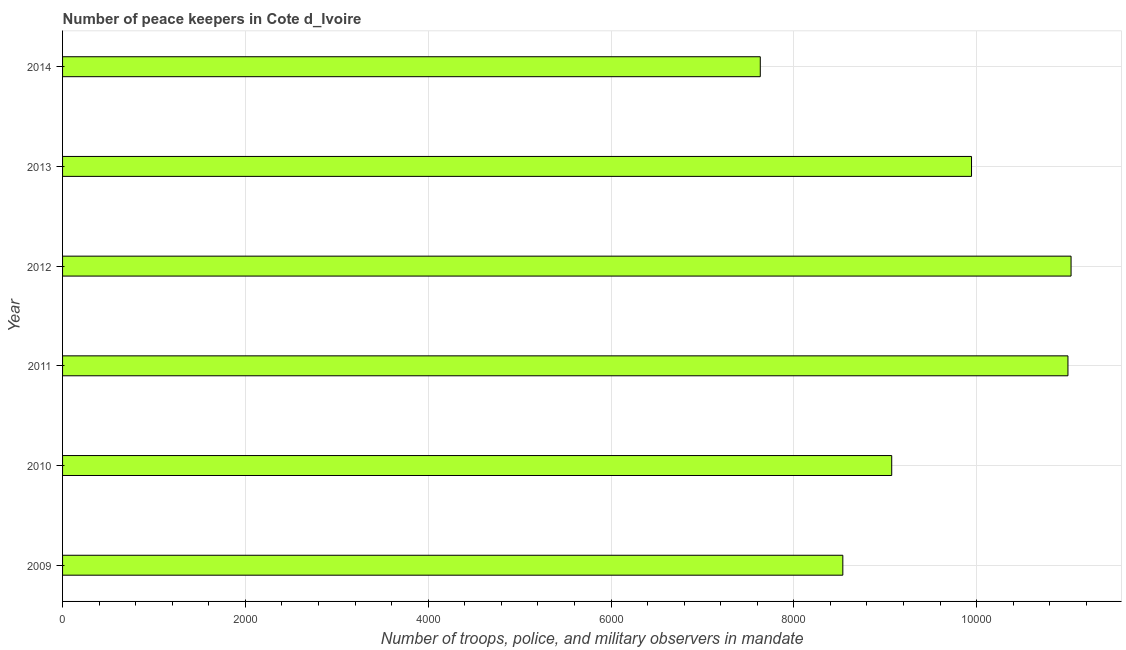What is the title of the graph?
Provide a short and direct response. Number of peace keepers in Cote d_Ivoire. What is the label or title of the X-axis?
Ensure brevity in your answer.  Number of troops, police, and military observers in mandate. What is the number of peace keepers in 2014?
Give a very brief answer. 7633. Across all years, what is the maximum number of peace keepers?
Offer a terse response. 1.10e+04. Across all years, what is the minimum number of peace keepers?
Offer a very short reply. 7633. What is the sum of the number of peace keepers?
Provide a short and direct response. 5.72e+04. What is the difference between the number of peace keepers in 2012 and 2013?
Keep it short and to the point. 1089. What is the average number of peace keepers per year?
Keep it short and to the point. 9536. What is the median number of peace keepers?
Provide a short and direct response. 9507.5. In how many years, is the number of peace keepers greater than 9600 ?
Your answer should be compact. 3. What is the ratio of the number of peace keepers in 2012 to that in 2014?
Provide a succinct answer. 1.45. Is the number of peace keepers in 2009 less than that in 2014?
Give a very brief answer. No. What is the difference between the highest and the second highest number of peace keepers?
Keep it short and to the point. 34. What is the difference between the highest and the lowest number of peace keepers?
Offer a terse response. 3400. Are all the bars in the graph horizontal?
Offer a very short reply. Yes. How many years are there in the graph?
Make the answer very short. 6. What is the difference between two consecutive major ticks on the X-axis?
Offer a very short reply. 2000. Are the values on the major ticks of X-axis written in scientific E-notation?
Your response must be concise. No. What is the Number of troops, police, and military observers in mandate of 2009?
Provide a short and direct response. 8536. What is the Number of troops, police, and military observers in mandate in 2010?
Give a very brief answer. 9071. What is the Number of troops, police, and military observers in mandate of 2011?
Your response must be concise. 1.10e+04. What is the Number of troops, police, and military observers in mandate in 2012?
Provide a succinct answer. 1.10e+04. What is the Number of troops, police, and military observers in mandate of 2013?
Make the answer very short. 9944. What is the Number of troops, police, and military observers in mandate in 2014?
Make the answer very short. 7633. What is the difference between the Number of troops, police, and military observers in mandate in 2009 and 2010?
Your answer should be very brief. -535. What is the difference between the Number of troops, police, and military observers in mandate in 2009 and 2011?
Provide a short and direct response. -2463. What is the difference between the Number of troops, police, and military observers in mandate in 2009 and 2012?
Give a very brief answer. -2497. What is the difference between the Number of troops, police, and military observers in mandate in 2009 and 2013?
Give a very brief answer. -1408. What is the difference between the Number of troops, police, and military observers in mandate in 2009 and 2014?
Your answer should be very brief. 903. What is the difference between the Number of troops, police, and military observers in mandate in 2010 and 2011?
Ensure brevity in your answer.  -1928. What is the difference between the Number of troops, police, and military observers in mandate in 2010 and 2012?
Offer a terse response. -1962. What is the difference between the Number of troops, police, and military observers in mandate in 2010 and 2013?
Offer a very short reply. -873. What is the difference between the Number of troops, police, and military observers in mandate in 2010 and 2014?
Offer a very short reply. 1438. What is the difference between the Number of troops, police, and military observers in mandate in 2011 and 2012?
Offer a very short reply. -34. What is the difference between the Number of troops, police, and military observers in mandate in 2011 and 2013?
Give a very brief answer. 1055. What is the difference between the Number of troops, police, and military observers in mandate in 2011 and 2014?
Give a very brief answer. 3366. What is the difference between the Number of troops, police, and military observers in mandate in 2012 and 2013?
Your response must be concise. 1089. What is the difference between the Number of troops, police, and military observers in mandate in 2012 and 2014?
Your answer should be very brief. 3400. What is the difference between the Number of troops, police, and military observers in mandate in 2013 and 2014?
Offer a terse response. 2311. What is the ratio of the Number of troops, police, and military observers in mandate in 2009 to that in 2010?
Keep it short and to the point. 0.94. What is the ratio of the Number of troops, police, and military observers in mandate in 2009 to that in 2011?
Offer a very short reply. 0.78. What is the ratio of the Number of troops, police, and military observers in mandate in 2009 to that in 2012?
Keep it short and to the point. 0.77. What is the ratio of the Number of troops, police, and military observers in mandate in 2009 to that in 2013?
Ensure brevity in your answer.  0.86. What is the ratio of the Number of troops, police, and military observers in mandate in 2009 to that in 2014?
Make the answer very short. 1.12. What is the ratio of the Number of troops, police, and military observers in mandate in 2010 to that in 2011?
Ensure brevity in your answer.  0.82. What is the ratio of the Number of troops, police, and military observers in mandate in 2010 to that in 2012?
Offer a terse response. 0.82. What is the ratio of the Number of troops, police, and military observers in mandate in 2010 to that in 2013?
Keep it short and to the point. 0.91. What is the ratio of the Number of troops, police, and military observers in mandate in 2010 to that in 2014?
Keep it short and to the point. 1.19. What is the ratio of the Number of troops, police, and military observers in mandate in 2011 to that in 2013?
Give a very brief answer. 1.11. What is the ratio of the Number of troops, police, and military observers in mandate in 2011 to that in 2014?
Offer a terse response. 1.44. What is the ratio of the Number of troops, police, and military observers in mandate in 2012 to that in 2013?
Keep it short and to the point. 1.11. What is the ratio of the Number of troops, police, and military observers in mandate in 2012 to that in 2014?
Give a very brief answer. 1.45. What is the ratio of the Number of troops, police, and military observers in mandate in 2013 to that in 2014?
Your answer should be compact. 1.3. 